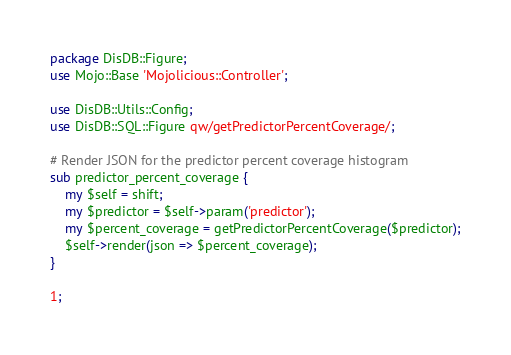<code> <loc_0><loc_0><loc_500><loc_500><_Perl_>package DisDB::Figure;
use Mojo::Base 'Mojolicious::Controller';

use DisDB::Utils::Config;
use DisDB::SQL::Figure qw/getPredictorPercentCoverage/;

# Render JSON for the predictor percent coverage histogram
sub predictor_percent_coverage {
	my $self = shift;
	my $predictor = $self->param('predictor');
    my $percent_coverage = getPredictorPercentCoverage($predictor);
    $self->render(json => $percent_coverage);
}

1;
</code> 